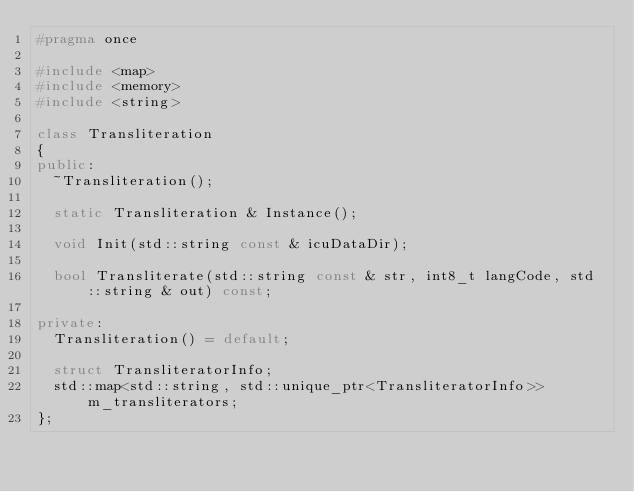<code> <loc_0><loc_0><loc_500><loc_500><_C++_>#pragma once

#include <map>
#include <memory>
#include <string>

class Transliteration
{
public:
  ~Transliteration();

  static Transliteration & Instance();

  void Init(std::string const & icuDataDir);

  bool Transliterate(std::string const & str, int8_t langCode, std::string & out) const;

private:
  Transliteration() = default;

  struct TransliteratorInfo;
  std::map<std::string, std::unique_ptr<TransliteratorInfo>> m_transliterators;
};
</code> 